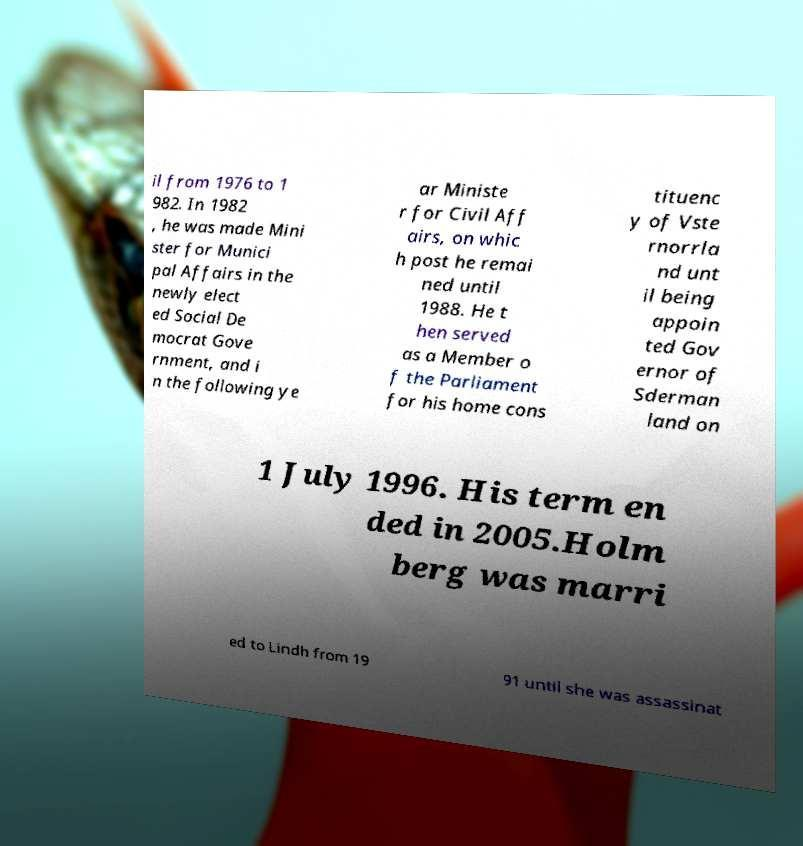Can you accurately transcribe the text from the provided image for me? il from 1976 to 1 982. In 1982 , he was made Mini ster for Munici pal Affairs in the newly elect ed Social De mocrat Gove rnment, and i n the following ye ar Ministe r for Civil Aff airs, on whic h post he remai ned until 1988. He t hen served as a Member o f the Parliament for his home cons tituenc y of Vste rnorrla nd unt il being appoin ted Gov ernor of Sderman land on 1 July 1996. His term en ded in 2005.Holm berg was marri ed to Lindh from 19 91 until she was assassinat 